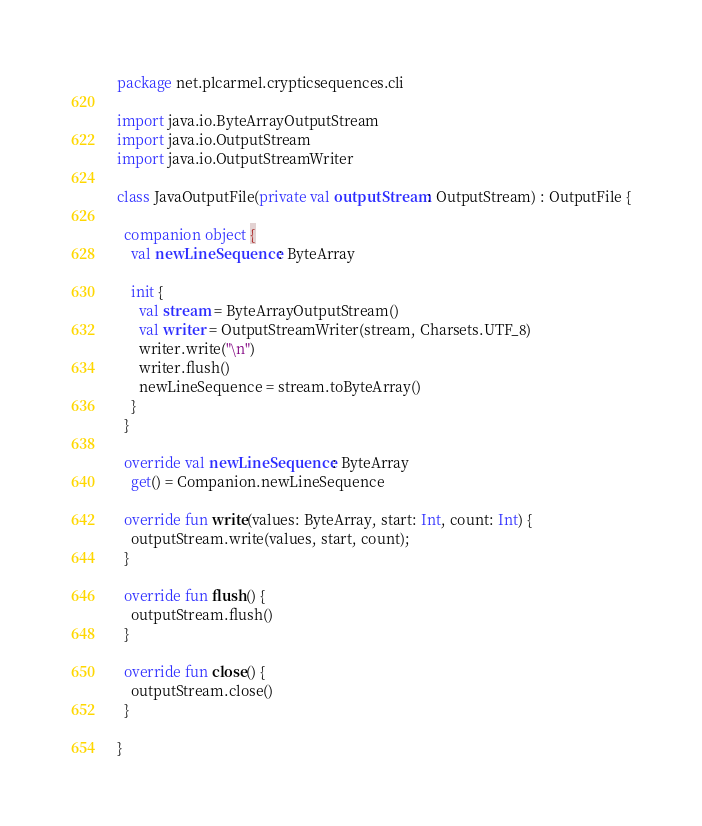<code> <loc_0><loc_0><loc_500><loc_500><_Kotlin_>package net.plcarmel.crypticsequences.cli

import java.io.ByteArrayOutputStream
import java.io.OutputStream
import java.io.OutputStreamWriter

class JavaOutputFile(private val outputStream: OutputStream) : OutputFile {

  companion object {
    val newLineSequence: ByteArray

    init {
      val stream = ByteArrayOutputStream()
      val writer = OutputStreamWriter(stream, Charsets.UTF_8)
      writer.write("\n")
      writer.flush()
      newLineSequence = stream.toByteArray()
    }
  }

  override val newLineSequence: ByteArray
    get() = Companion.newLineSequence

  override fun write(values: ByteArray, start: Int, count: Int) {
    outputStream.write(values, start, count);
  }

  override fun flush() {
    outputStream.flush()
  }

  override fun close() {
    outputStream.close()
  }

}
</code> 